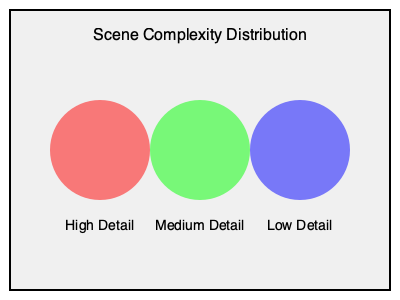Given a scene with the complexity distribution shown above, where red represents high detail areas, green represents medium detail areas, and blue represents low detail areas, which rendering algorithm would be most efficient for real-time performance on a GPU with limited memory bandwidth? Assume the scene contains both static and dynamic objects, and requires realistic lighting and shadows. To determine the most efficient rendering algorithm, we need to consider the scene characteristics and hardware constraints:

1. Scene complexity:
   - High detail areas (red): Require more computational resources
   - Medium detail areas (green): Balanced resource requirements
   - Low detail areas (blue): Require fewer resources

2. GPU constraints:
   - Limited memory bandwidth: Suggests the need for efficient memory usage

3. Scene requirements:
   - Real-time performance: Favors algorithms with lower computational complexity
   - Static and dynamic objects: Requires flexibility in rendering approach
   - Realistic lighting and shadows: Needs advanced shading techniques

Considering these factors, the most efficient algorithm would be a hybrid approach combining:

a) Deferred Rendering: 
   - Separates geometry and lighting passes, reducing overdraw
   - Efficient for scenes with many lights
   - Works well with both static and dynamic objects

b) Level of Detail (LOD) techniques:
   - Adapt mesh complexity based on distance or importance
   - Matches the varying detail levels in the scene

c) Clustered Shading:
   - Divides the scene into 3D clusters for efficient light culling
   - Balances performance and memory usage

d) Screen Space Ambient Occlusion (SSAO):
   - Approximates ambient occlusion in screen space
   - Adds realism without excessive computational cost

e) Temporal Anti-Aliasing (TAA):
   - Reduces aliasing artifacts using information from previous frames
   - Improves image quality with minimal performance impact

This hybrid approach, often referred to as "Clustered Deferred Rendering with LOD and TAA," provides a good balance between performance and visual quality for the given scene and hardware constraints.
Answer: Clustered Deferred Rendering with LOD and TAA 